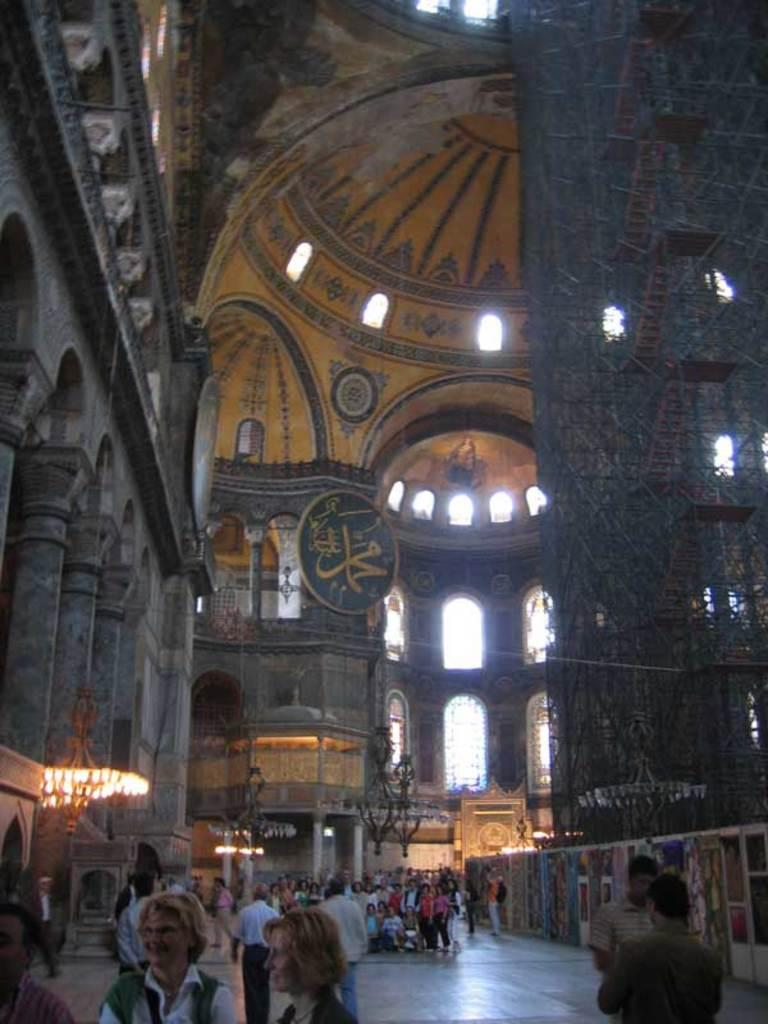Where is the setting of the image? The image is inside a building. What can be seen through the windows in the image? There are no windows visible in the image. Who or what can be seen in the image? People are visible in the image. What is on the wall in the image? There are posters on the wall in the image. What type of meat is being served in the image? There is no meal or meat present in the image. What question is being asked by the person in the image? There is no person asking a question in the image. 